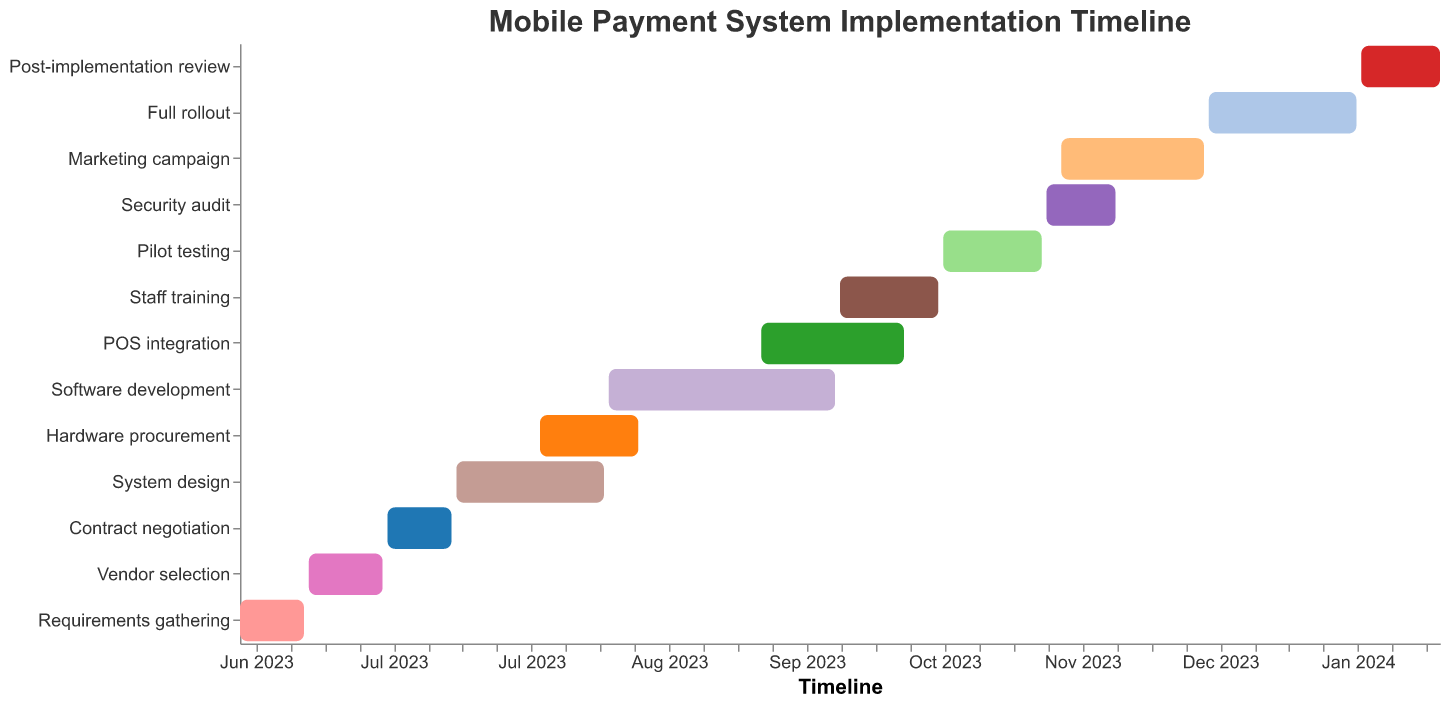What's the duration of the "System design" phase? Look at the "System design" task and observe the "Duration" value in the figure.
Answer: 31 days When does the "Pilot testing" phase end? Identify the "Pilot testing" task, and check the "End Date" for that task shown in the tool-tip or next to the bar.
Answer: 2023-11-11 What phase takes the longest duration? Compare the "Duration" values of all the tasks shown in the figure. Identify the largest value.
Answer: Software development When does the "Staff training" phase start and end? Locate the "Staff training" task and refer to the "Start Date" and "End Date" values in the figure.
Answer: 2023-10-01 to 2023-10-21 How long is the total duration of "Marketing campaign" and "Full rollout"? Find the "Duration" values for both "Marketing campaign" and "Full rollout" tasks, then add them together.
Answer: 30 + 31 = 61 days Which tasks are scheduled to be completed in October 2023? Check the "End Date" for all tasks and identify the ones that end in October 2023.
Answer: POS integration and Staff training Which phases overlap with the "POS integration"? Identify "POS integration"'s timeline then find other tasks whose timelines overlap with it.
Answer: Software development, Staff training During which months does the "Software development" task take place? Look at the "Software development" task and check its "Start Date" and "End Date" to determine the months.
Answer: August 2023 to September 2023 How many days are planned for tasks after the "Full rollout"? Sum the "Duration" values for tasks starting after the "Full rollout" ends. Specifically, the "Post-implementation review".
Answer: 17 days What two tasks have the exact same duration? Compare the "Duration" values across all tasks to find pairs with the same value.
Answer: Requirements gathering and Contract negotiation (both 14 days) 